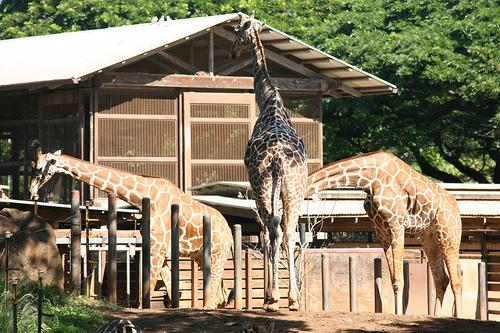Question: where is the picture taken?
Choices:
A. Botanical garden.
B. Dog park.
C. Zoo.
D. Front yard.
Answer with the letter. Answer: C Question: what is standing?
Choices:
A. Zebras.
B. People.
C. Giraffes.
D. Dogs.
Answer with the letter. Answer: C Question: how many giraffes?
Choices:
A. Five.
B. Three.
C. Six.
D. Seven.
Answer with the letter. Answer: B Question: why are the giraffes standing?
Choices:
A. To eat.
B. To walk.
C. To look around.
D. To stretch.
Answer with the letter. Answer: A Question: what is green?
Choices:
A. Lettuce.
B. Brocolli.
C. Leaves.
D. Grass.
Answer with the letter. Answer: C Question: who took the picture?
Choices:
A. Man.
B. Woman.
C. Little boy.
D. Old man.
Answer with the letter. Answer: B 